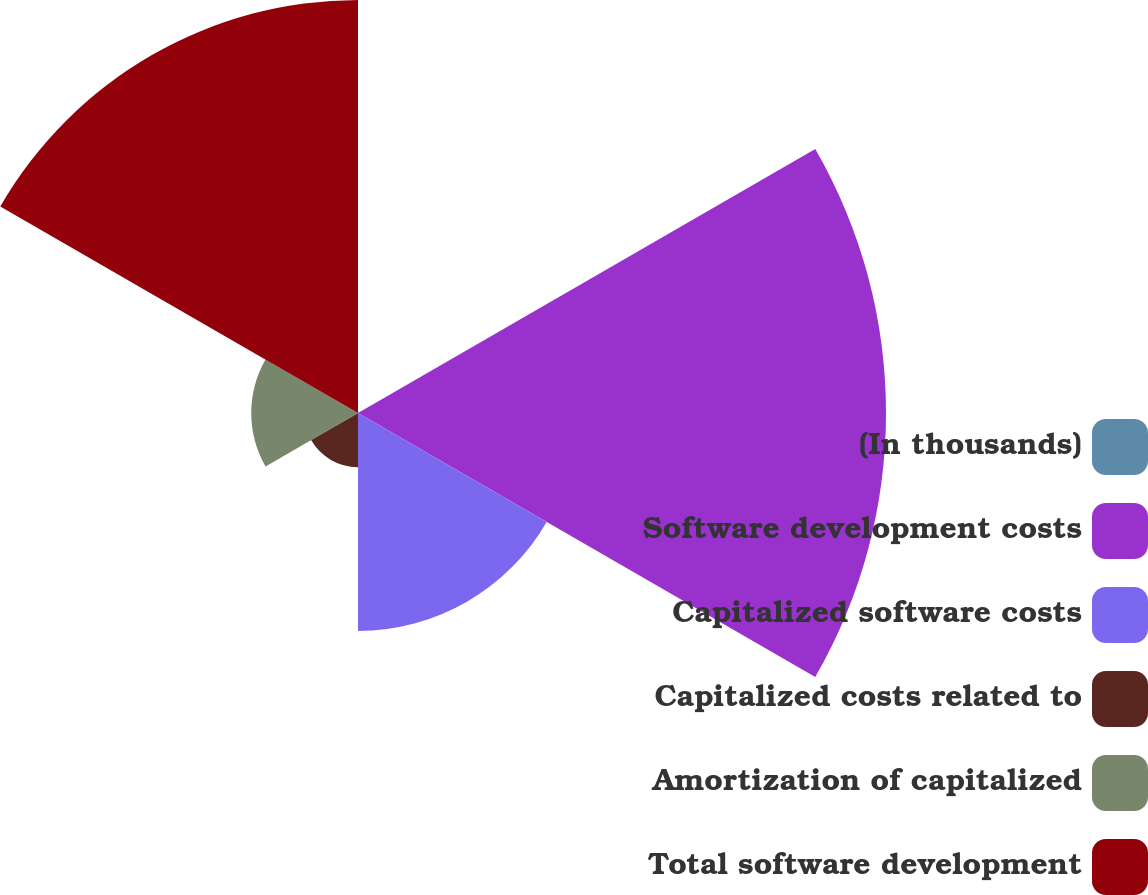Convert chart to OTSL. <chart><loc_0><loc_0><loc_500><loc_500><pie_chart><fcel>(In thousands)<fcel>Software development costs<fcel>Capitalized software costs<fcel>Capitalized costs related to<fcel>Amortization of capitalized<fcel>Total software development<nl><fcel>0.11%<fcel>39.96%<fcel>16.49%<fcel>4.1%<fcel>8.08%<fcel>31.26%<nl></chart> 